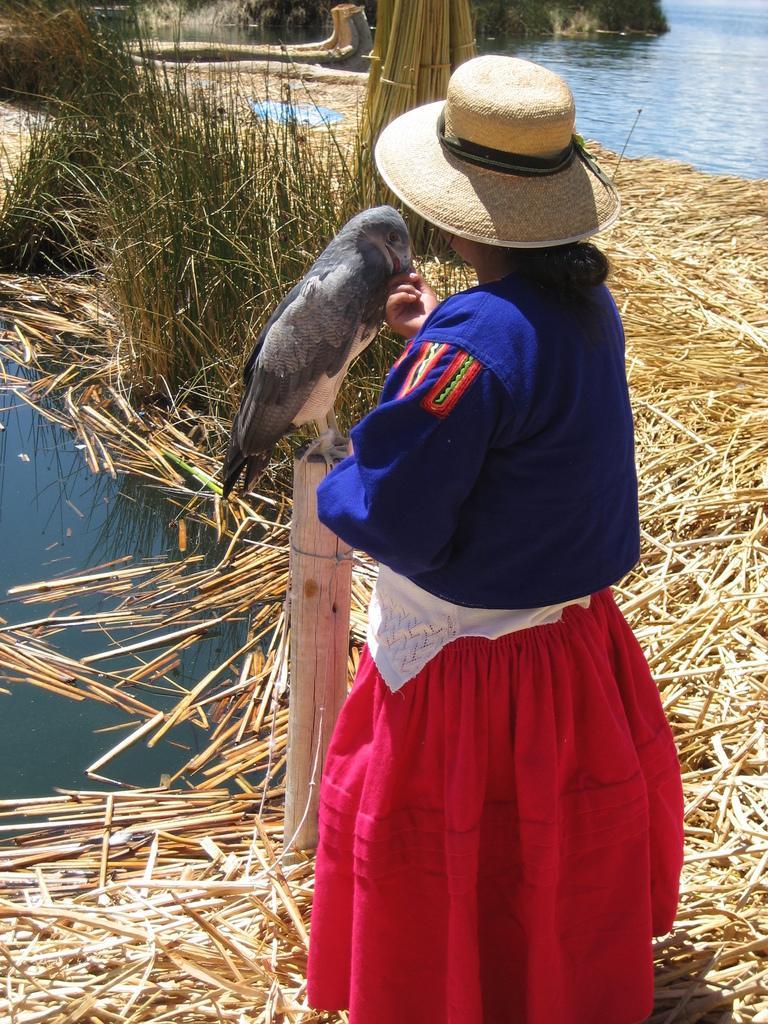Please provide a concise description of this image. In this image I can see a person standing, wearing a hat, blue shirt and red skirt. There is a bird on a wooden pole. There are dry twigs and plants. There is water. 